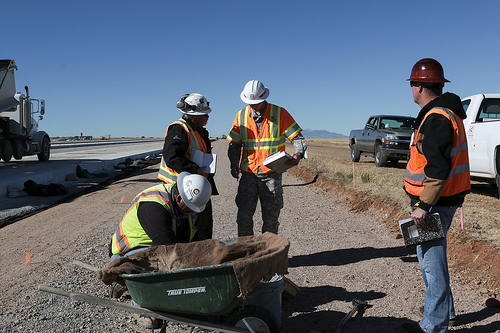<image>
Is there a man behind the truck? No. The man is not behind the truck. From this viewpoint, the man appears to be positioned elsewhere in the scene. 